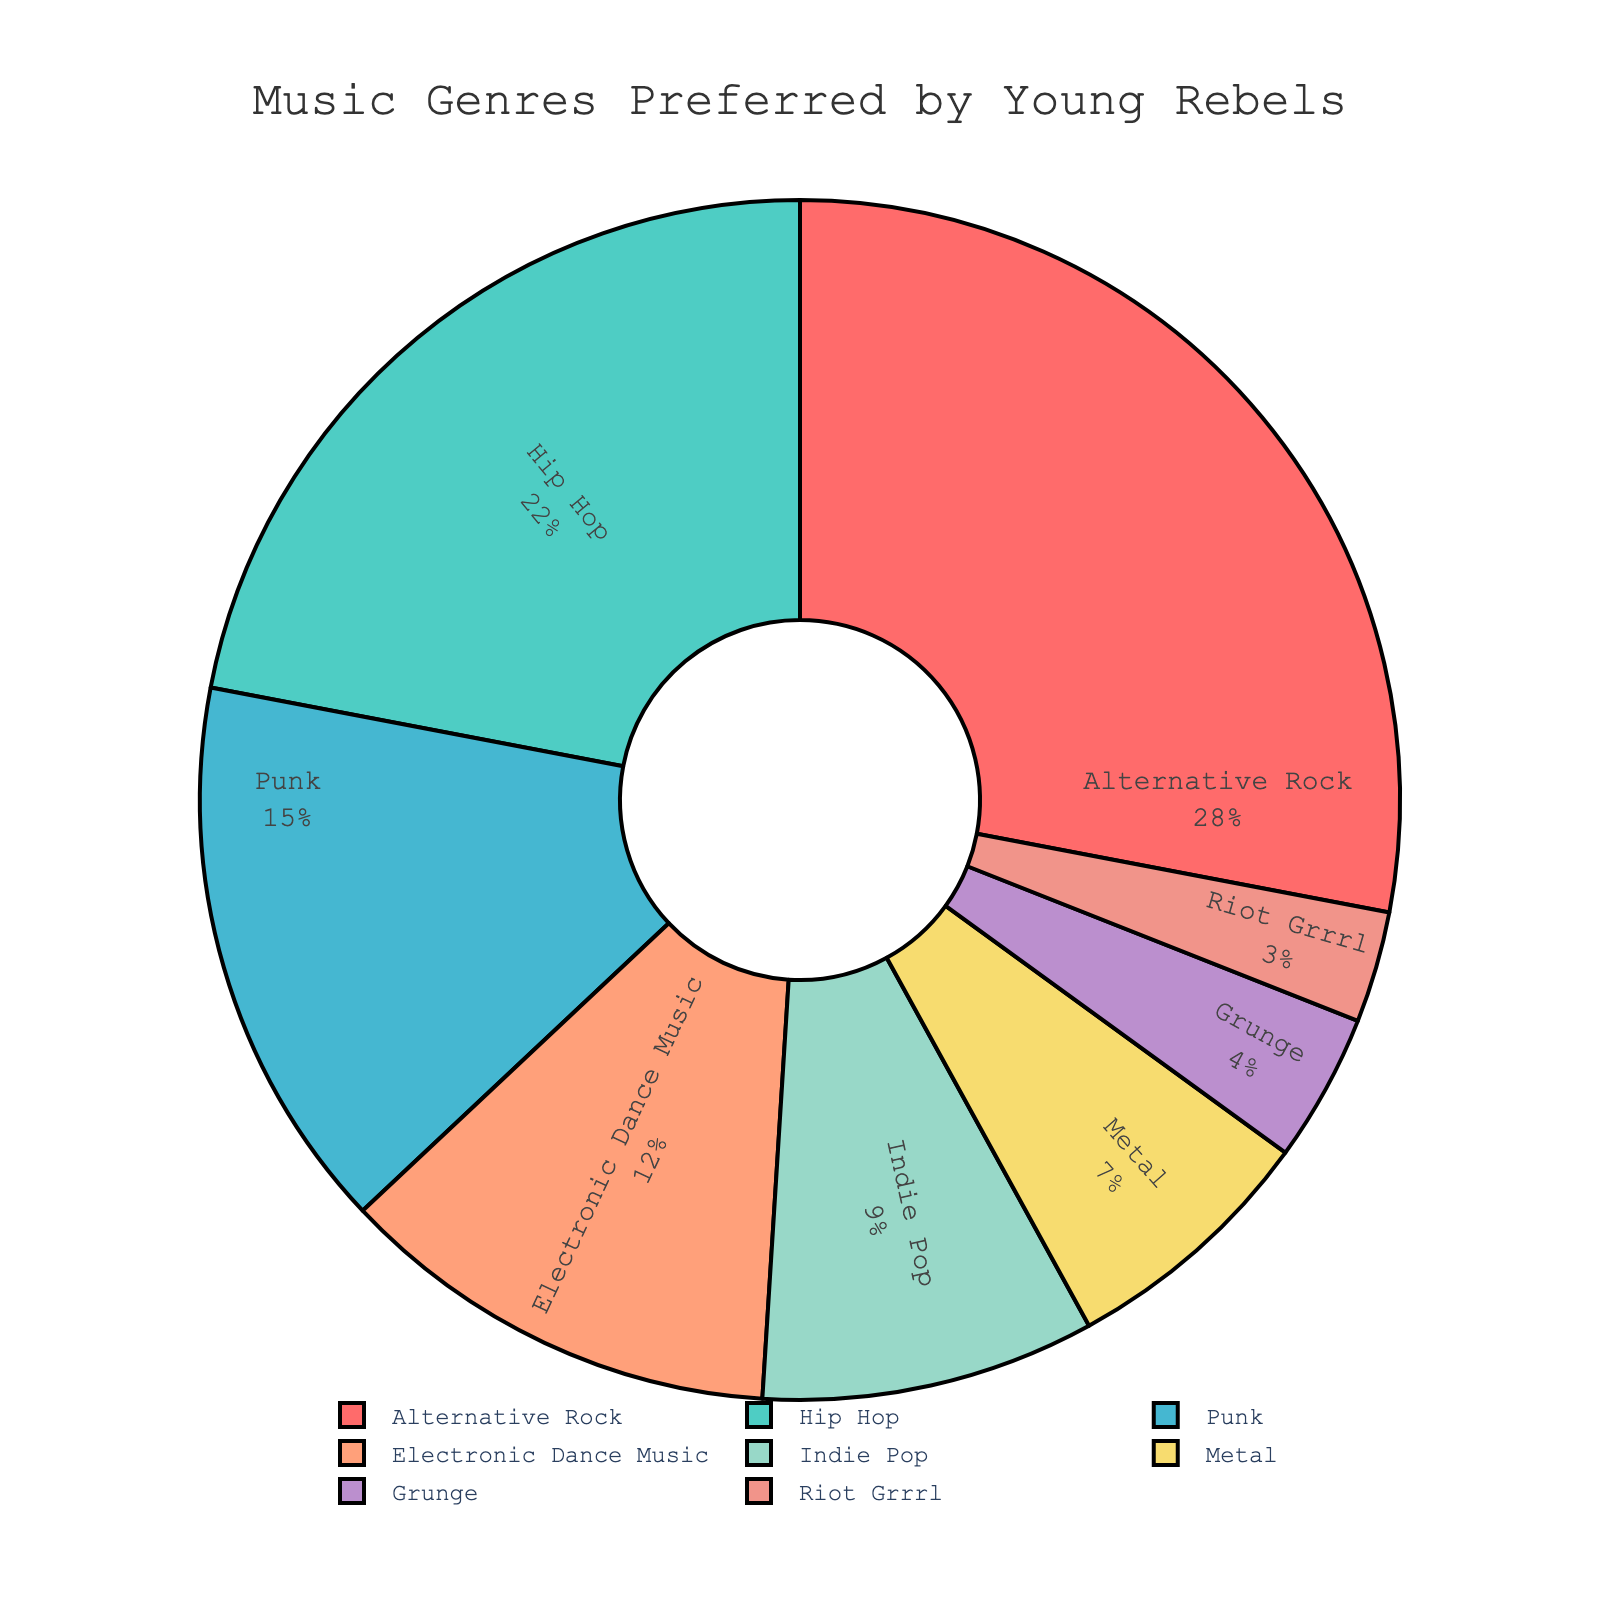What is the most preferred music genre among young rebels? The pie chart shows the largest slice, labeled "Alternative Rock," with a percentage of 28%. This indicates that Alternative Rock is the most preferred genre among young rebels.
Answer: Alternative Rock Which music genre is less preferred: Metal or Grunge? By examining the pie chart, we can see that Metal has a larger slice labeled with 7%, while Grunge has a smaller slice labeled with 4%. Therefore, Grunge is less preferred than Metal.
Answer: Grunge Combined, what percentage of young rebels prefer Hip Hop and Indie Pop? To find the combined preference for Hip Hop and Indie Pop, we add their individual percentages. Hip Hop is 22% and Indie Pop is 9%. Adding these gives 22% + 9% = 31%.
Answer: 31% How does the percentage of people who prefer Punk compare to those who prefer Electronic Dance Music? The pie chart shows that Punk is preferred by 15%, while Electronic Dance Music is preferred by 12%. Thus, more people prefer Punk compared to Electronic Dance Music.
Answer: Punk What are the two least preferred music genres by young rebels? By examining the pie chart, we find that the smallest slices belong to Grunge (4%) and Riot Grrrl (3%). These are the two least preferred genres.
Answer: Grunge and Riot Grrrl What is the proportion of individuals preferring Metal compared to those preferring Punk? The pie chart shows Metal at 7% and Punk at 15%. To find the proportion, we divide 7 by 15, which simplifies to approximately 0.47.
Answer: Approximately 0.47 What percentage of young rebels prefer genres other than Alternative Rock and Hip Hop? To find this, we subtract the combined percentage of Alternative Rock (28%) and Hip Hop (22%) from 100%. So, 100% - (28% + 22%) = 100% - 50% = 50%.
Answer: 50% What color represents the slice for Indie Pop and what percentage does it occupy? The pie chart has a labeled slice for Indie Pop at 9%, and it is represented by a distinct color, which is light blue.
Answer: Light blue, 9% Which genre is preferred by nearly a quarter of the young rebels? The pie chart displays a genre labeled with 22%, which is Hip Hop. This is close to a quarter of the total percentage.
Answer: Hip Hop 